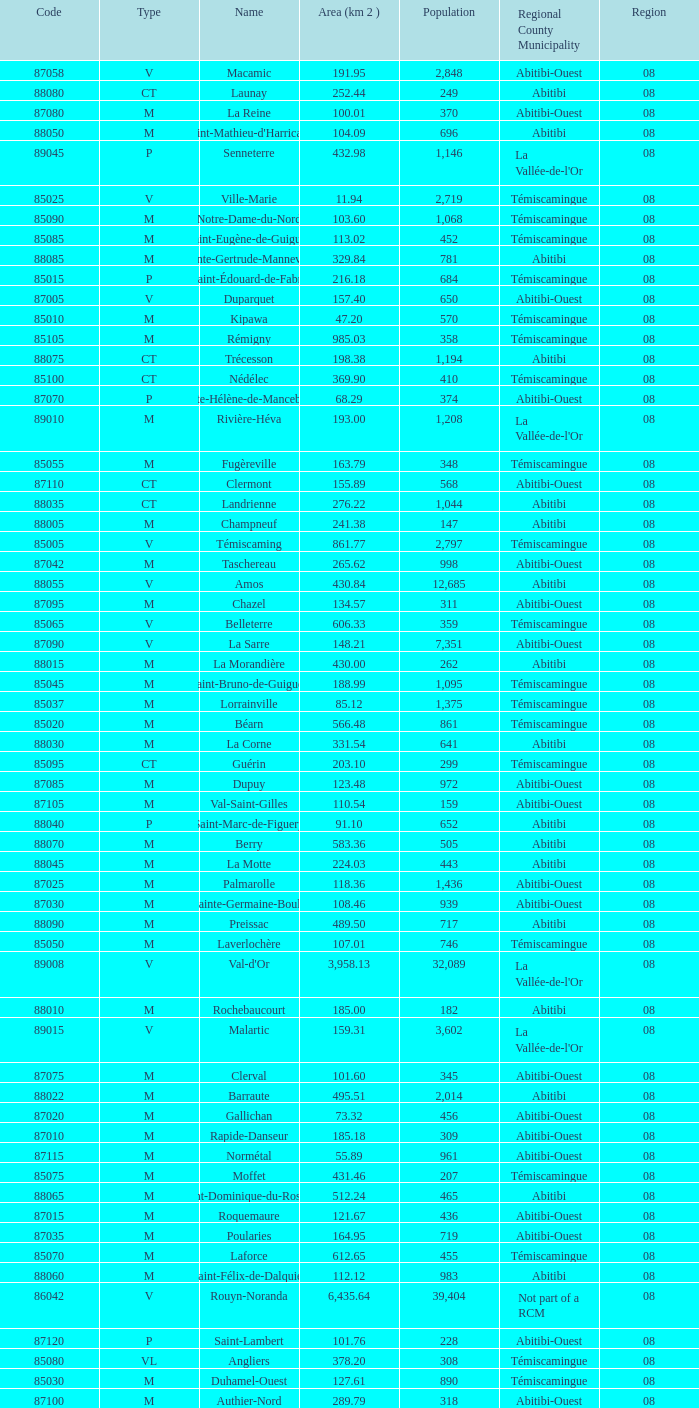What is the km2 area for the population of 311? 134.57. 